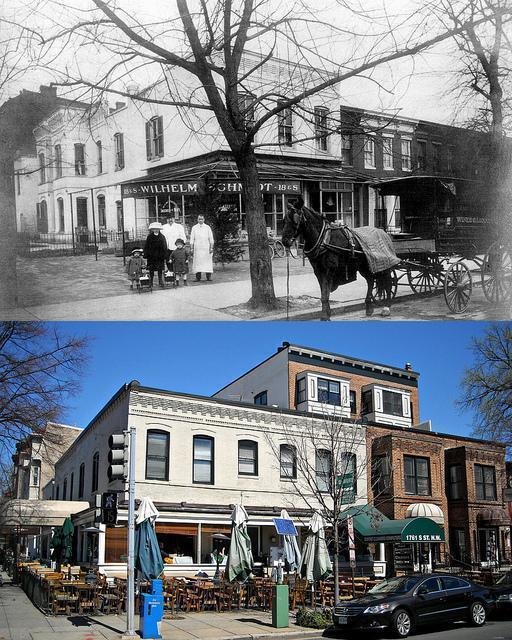Who do the umbrellas belong to?
Make your selection and explain in format: 'Answer: answer
Rationale: rationale.'
Options: Residents, store, city, restaurant. Answer: restaurant.
Rationale: The umbrellas are in the outdoor dining area of a restaurant and belong to that establishment. 